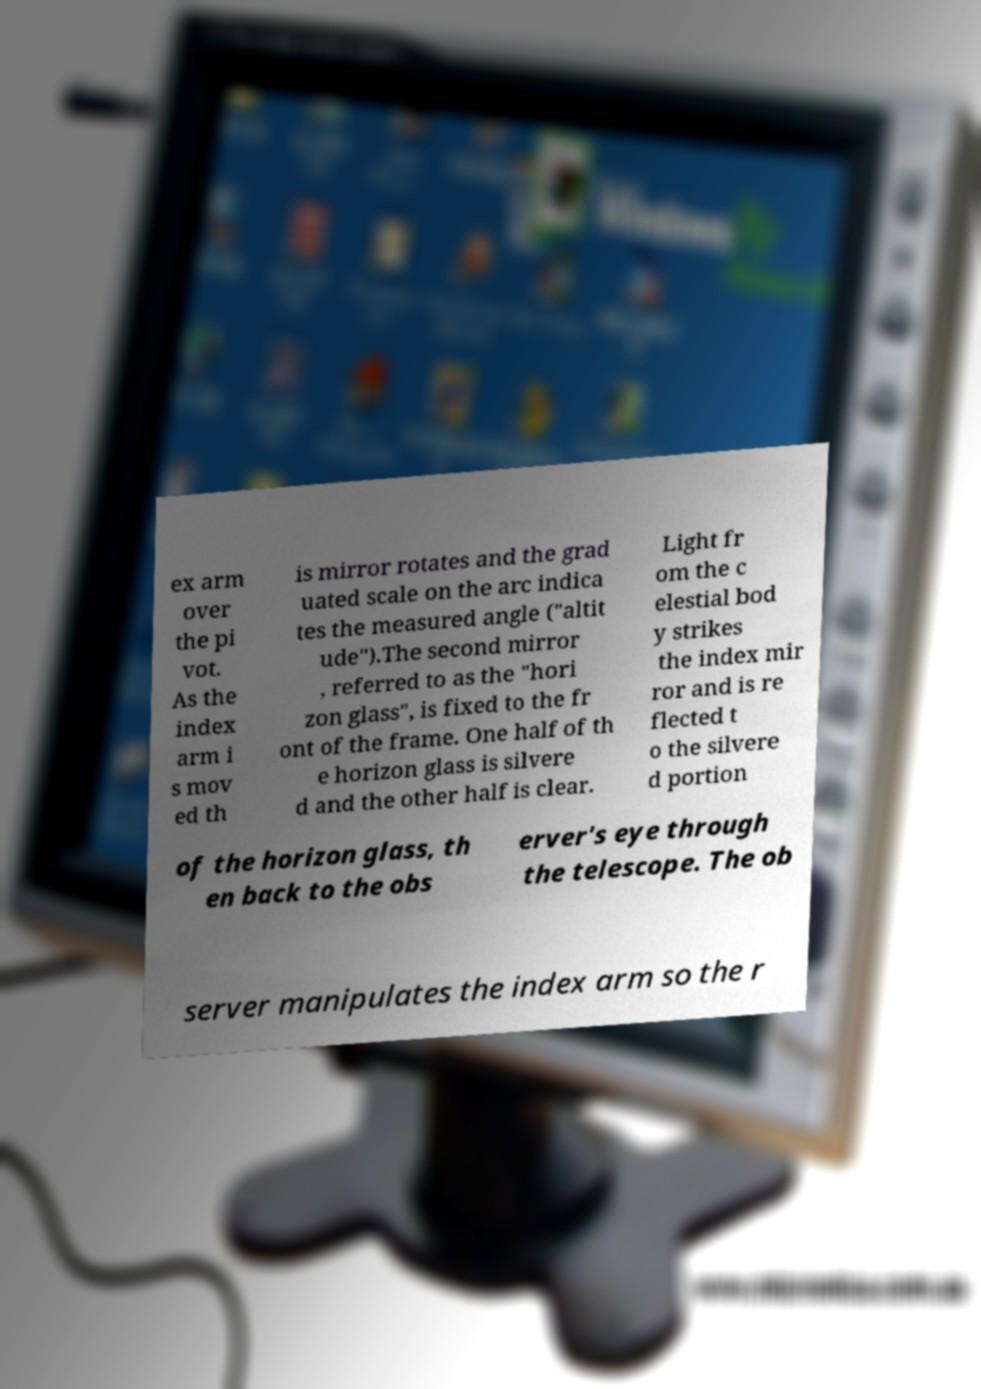Please read and relay the text visible in this image. What does it say? ex arm over the pi vot. As the index arm i s mov ed th is mirror rotates and the grad uated scale on the arc indica tes the measured angle ("altit ude").The second mirror , referred to as the "hori zon glass", is fixed to the fr ont of the frame. One half of th e horizon glass is silvere d and the other half is clear. Light fr om the c elestial bod y strikes the index mir ror and is re flected t o the silvere d portion of the horizon glass, th en back to the obs erver's eye through the telescope. The ob server manipulates the index arm so the r 